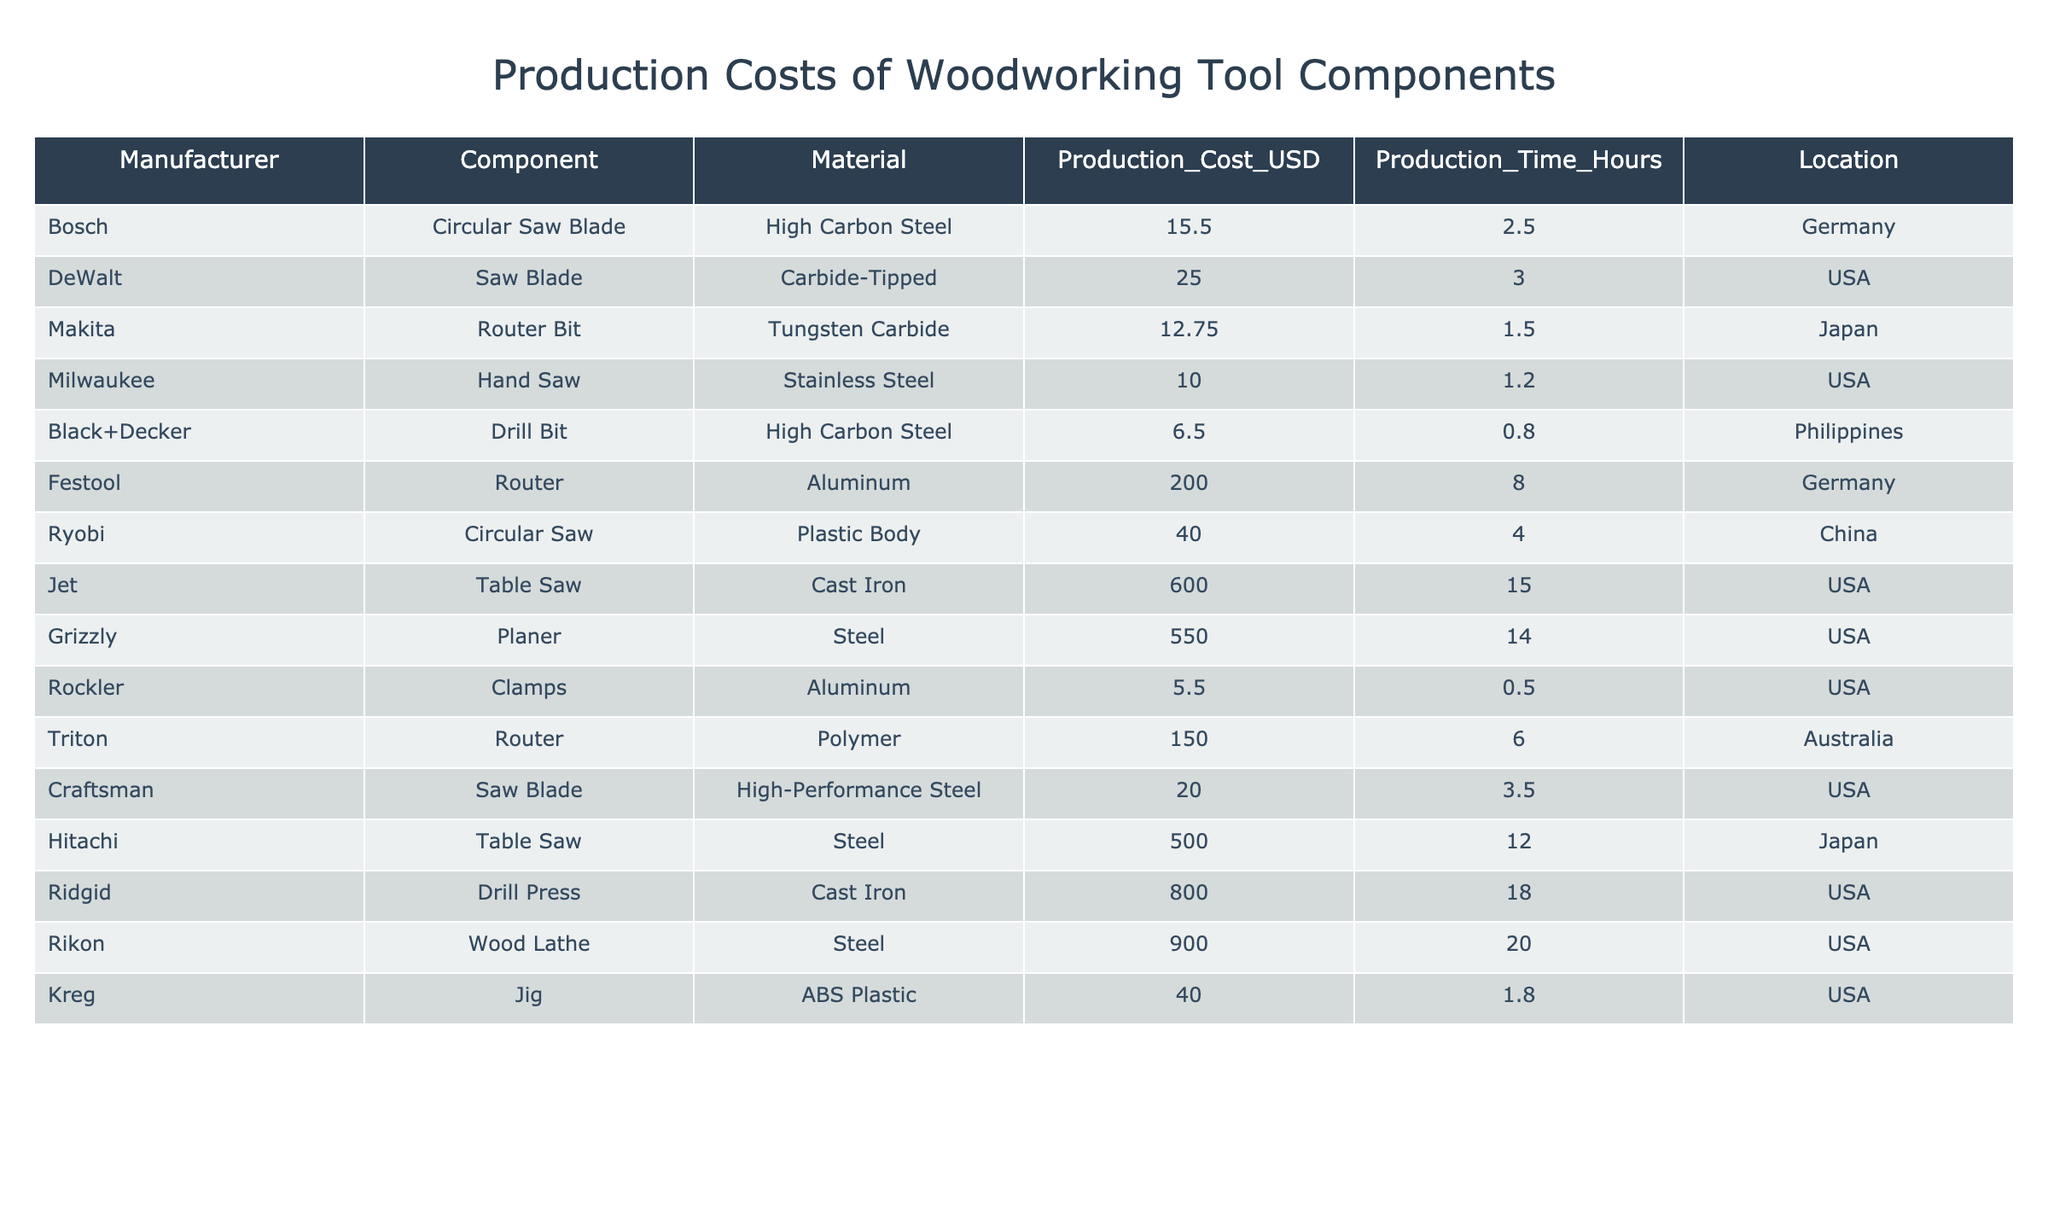What is the production cost of the Router Bit from Makita? The table lists the components and their associated production costs. For the Router Bit from Makita, the production cost is directly stated as $12.75.
Answer: 12.75 Which manufacturer has the highest production cost for a single woodworking tool component? By inspecting the table, I compare the production costs across all manufacturers. The Ridgid Drill Press has the highest cost at $800.00.
Answer: 800.00 How many manufacturers produce components made of Steel? I go through the table and count the entries where the Material is listed as Steel. There are three entries: Milwaukee's Hand Saw, Hitachi's Table Saw, and Rikon's Wood Lathe.
Answer: 3 What is the average production cost of components manufactured in the USA? First, I identify all components made in the USA from the table. Their costs are $25.00, $10.00, $40.00, $20.00, $600.00, $550.00, $800.00. Summing these up gives $2,045.00. There are 7 components, so the average is $2,045.00 / 7 = $292.14.
Answer: 292.14 Which component has the longest production time and what is it? I examine the production times for each component in the table. The component with the longest production time is the Rikon Wood Lathe, which takes 20 hours.
Answer: Rikon Wood Lathe Are there any components made of Aluminum? I check the Material column for any entries that mention Aluminum. The table shows that both the Festool Router and Rockler Clamps are made of Aluminum.
Answer: Yes What is the total production cost of the components that use High Carbon Steel? I locate the components using High Carbon Steel: Bosch's Circular Saw Blade at $15.50 and Black+Decker's Drill Bit at $6.50. The total cost is $15.50 + $6.50 = $22.00.
Answer: 22.00 What is the production cost difference between the most expensive and least expensive component? I find the most expensive component, which is the Rikon Wood Lathe at $900.00, and the least expensive, which is the Black+Decker Drill Bit at $6.50. The difference is $900.00 - $6.50 = $893.50.
Answer: 893.50 Which manufacturer produces a Circular Saw and what is its cost? I look for all entries in the table mentioning Circular Saw. I find Ryobi’s Circular Saw costing $40.00 and Bosch’s Circular Saw Blade at $15.50.
Answer: Ryobi, 40.00 How many components are made from Tungsten Carbide? I scan the table for entries that list Tungsten Carbide in the Material column. There is only one component, which is the Router Bit from Makita.
Answer: 1 